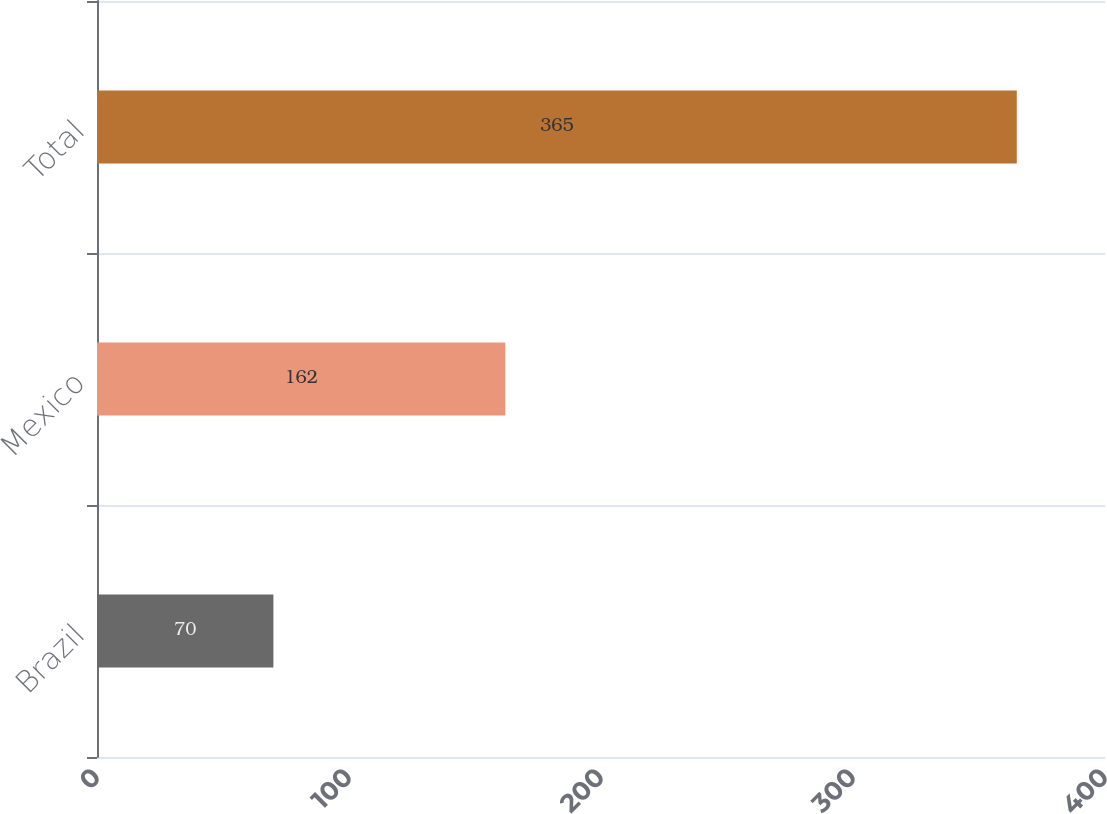<chart> <loc_0><loc_0><loc_500><loc_500><bar_chart><fcel>Brazil<fcel>Mexico<fcel>Total<nl><fcel>70<fcel>162<fcel>365<nl></chart> 